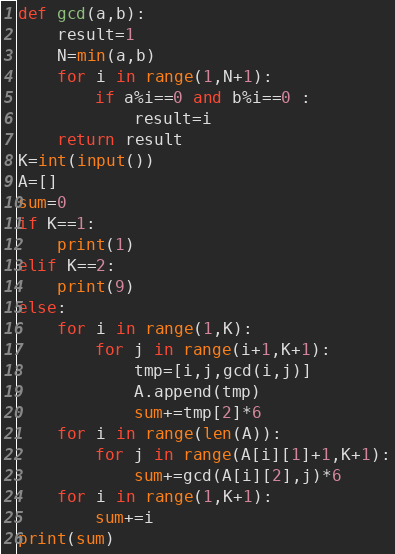<code> <loc_0><loc_0><loc_500><loc_500><_Python_>def gcd(a,b):
    result=1
    N=min(a,b)
    for i in range(1,N+1):
        if a%i==0 and b%i==0 :
            result=i
    return result
K=int(input())
A=[]
sum=0
if K==1:
    print(1)
elif K==2:
    print(9)
else:
    for i in range(1,K):
        for j in range(i+1,K+1):
            tmp=[i,j,gcd(i,j)]
            A.append(tmp)
            sum+=tmp[2]*6
    for i in range(len(A)):
        for j in range(A[i][1]+1,K+1):
            sum+=gcd(A[i][2],j)*6
    for i in range(1,K+1):
        sum+=i
print(sum)</code> 